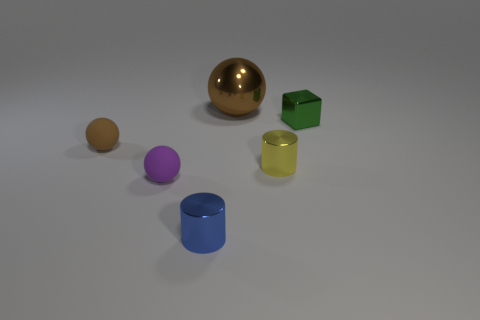There is another ball that is the same color as the metallic ball; what is its material?
Give a very brief answer. Rubber. How many big things are cyan metallic blocks or green objects?
Your answer should be very brief. 0. What shape is the brown thing that is in front of the small green thing?
Provide a succinct answer. Sphere. Is there another rubber thing of the same color as the big object?
Offer a terse response. Yes. There is a metal cylinder in front of the yellow thing; is it the same size as the brown ball that is in front of the brown metallic object?
Your answer should be very brief. Yes. Is the number of blue objects that are left of the tiny yellow cylinder greater than the number of purple matte spheres that are left of the tiny purple matte sphere?
Your answer should be very brief. Yes. Is there a tiny yellow ball that has the same material as the yellow cylinder?
Provide a short and direct response. No. The object that is in front of the block and to the right of the small blue cylinder is made of what material?
Your answer should be very brief. Metal. What color is the large metal sphere?
Offer a very short reply. Brown. How many big brown metallic things have the same shape as the yellow object?
Offer a very short reply. 0. 